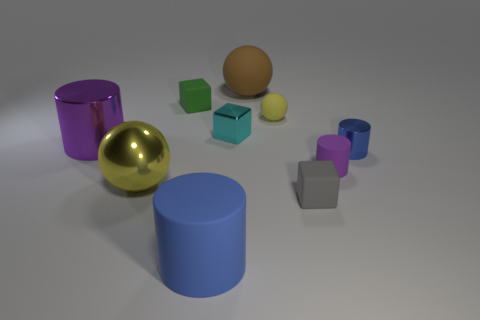Subtract all tiny rubber cylinders. How many cylinders are left? 3 Subtract all purple cylinders. How many cylinders are left? 2 Subtract 2 cubes. How many cubes are left? 1 Subtract all tiny matte balls. Subtract all blue matte cylinders. How many objects are left? 8 Add 3 purple rubber cylinders. How many purple rubber cylinders are left? 4 Add 8 tiny brown matte cubes. How many tiny brown matte cubes exist? 8 Subtract 0 brown blocks. How many objects are left? 10 Subtract all balls. How many objects are left? 7 Subtract all purple blocks. Subtract all blue spheres. How many blocks are left? 3 Subtract all yellow balls. How many green blocks are left? 1 